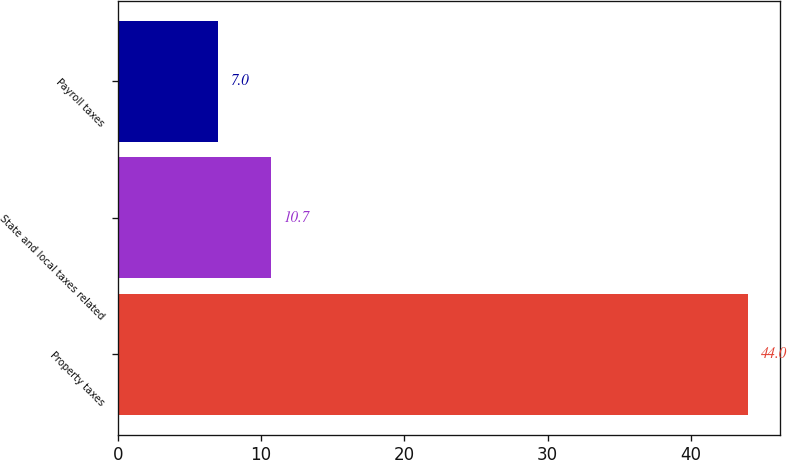Convert chart. <chart><loc_0><loc_0><loc_500><loc_500><bar_chart><fcel>Property taxes<fcel>State and local taxes related<fcel>Payroll taxes<nl><fcel>44<fcel>10.7<fcel>7<nl></chart> 